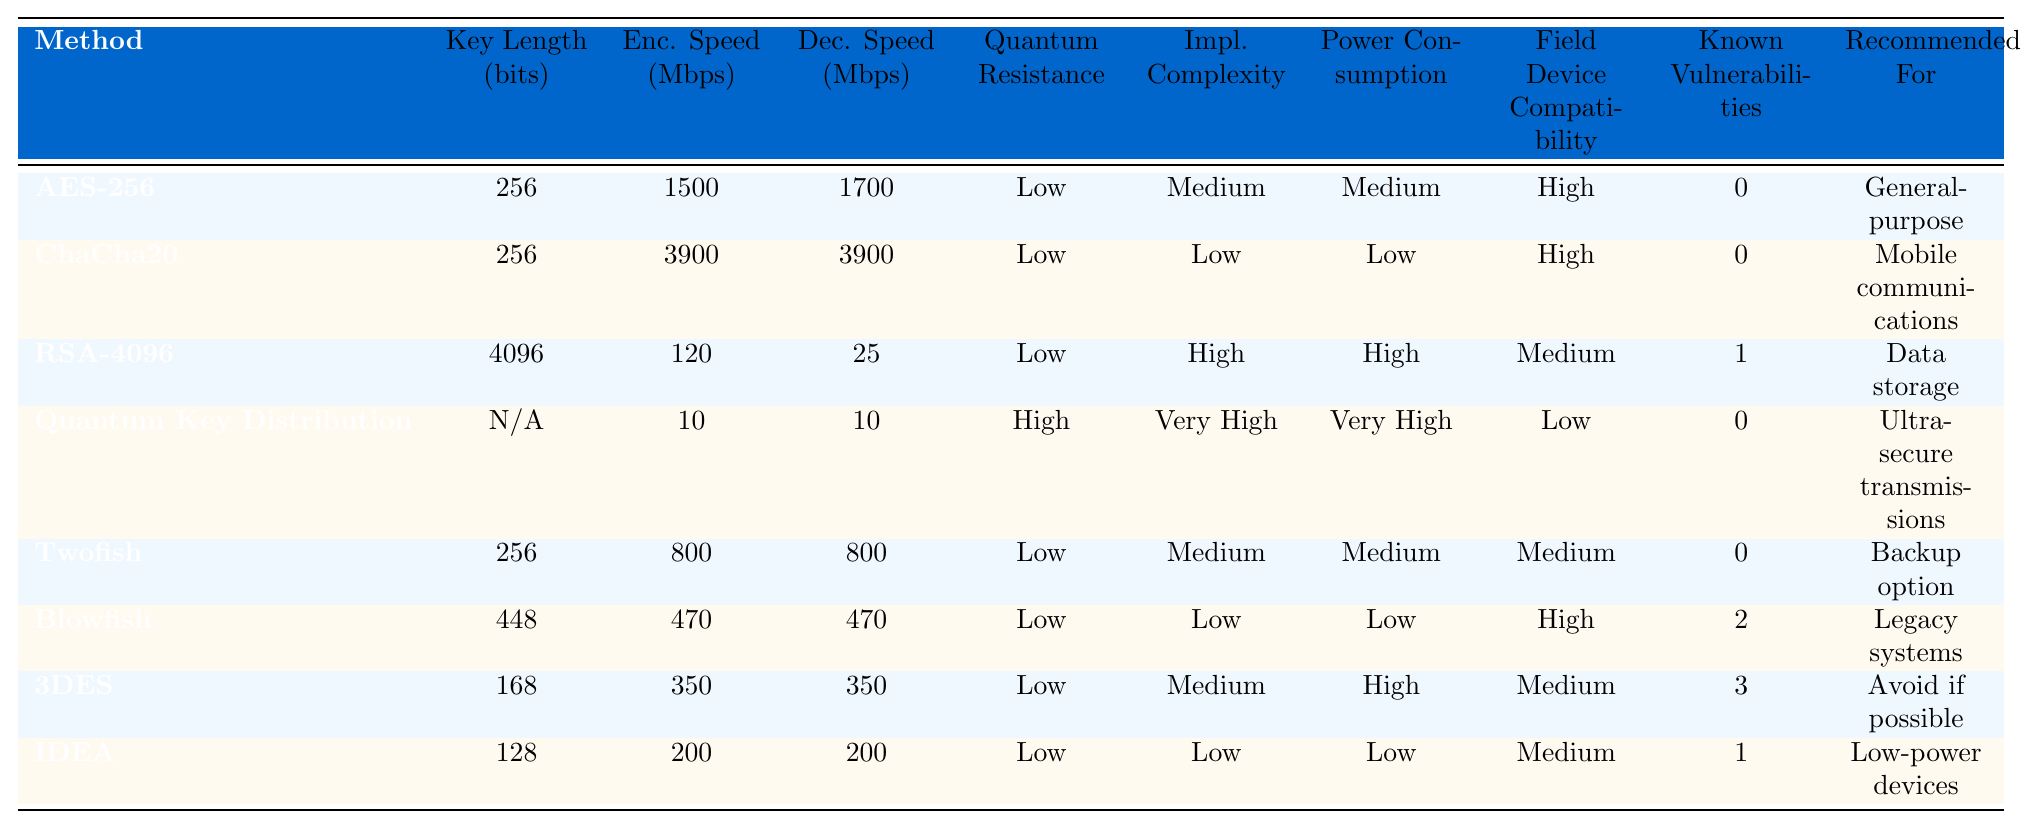What is the encryption speed of AES-256? According to the table, the encryption speed of AES-256 is 1500 Mbps as listed in the corresponding row under the "Enc. Speed (Mbps)" column.
Answer: 1500 Mbps Which encryption method has the highest decryption speed? Looking through the table, ChaCha20 has the highest decryption speed at 3900 Mbps, which is noted in the "Dec. Speed (Mbps)" column.
Answer: ChaCha20 Is Quantum Key Distribution resistant to quantum attacks? The table indicates that Quantum Key Distribution has "High" resistance to quantum attacks under the "Quantum Resistance" column, confirming that it is indeed resistant.
Answer: Yes How many known vulnerabilities does Blowfish have? From the table, Blowfish has 2 known vulnerabilities listed in the "Known Vulnerabilities" column.
Answer: 2 What is the average encryption speed of the encryption methods listed? The encryption speeds are: 1500, 3900, 120, 10, 800, 470, 350, 200. Summing these gives 1500 + 3900 + 120 + 10 + 800 + 470 + 350 + 200 = 7030 Mbps. Dividing by 8 (number of methods), the average speed is 7030 / 8 = 878.75 Mbps.
Answer: 878.75 Mbps Which encryption method is recommended for ultra-secure transmissions? The table suggests Quantum Key Distribution is recommended for ultra-secure transmissions, as specified in the "Recommended For" column.
Answer: Quantum Key Distribution How does the implementation complexity of RSA-4096 compare to that of Blowfish? The table shows RSA-4096 has "High" complexity and Blowfish has "Low" complexity. Therefore, RSA-4096 is more complex to implement than Blowfish.
Answer: More complex Which encryption method has the lowest power consumption? According to the table, ChaCha20 has the lowest power consumption listed as "Low".
Answer: ChaCha20 What is the decryption speed difference between Twofish and 3DES? Twofish has a decryption speed of 800 Mbps and 3DES has 350 Mbps. The difference in decryption speed is 800 - 350 = 450 Mbps.
Answer: 450 Mbps Are there any encryption methods with no known vulnerabilities? Referring to the table, both AES-256 and ChaCha20 have 0 known vulnerabilities, which means there are indeed encryption methods with no vulnerabilities.
Answer: Yes 